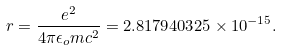Convert formula to latex. <formula><loc_0><loc_0><loc_500><loc_500>r = \frac { e ^ { 2 } } { 4 \pi \epsilon _ { o } m c ^ { 2 } } = 2 . 8 1 7 9 4 0 3 2 5 \times 1 0 ^ { - 1 5 } .</formula> 